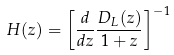<formula> <loc_0><loc_0><loc_500><loc_500>H ( z ) = \left [ \frac { d } { d z } \frac { D _ { L } ( z ) } { 1 + z } \right ] ^ { - 1 }</formula> 